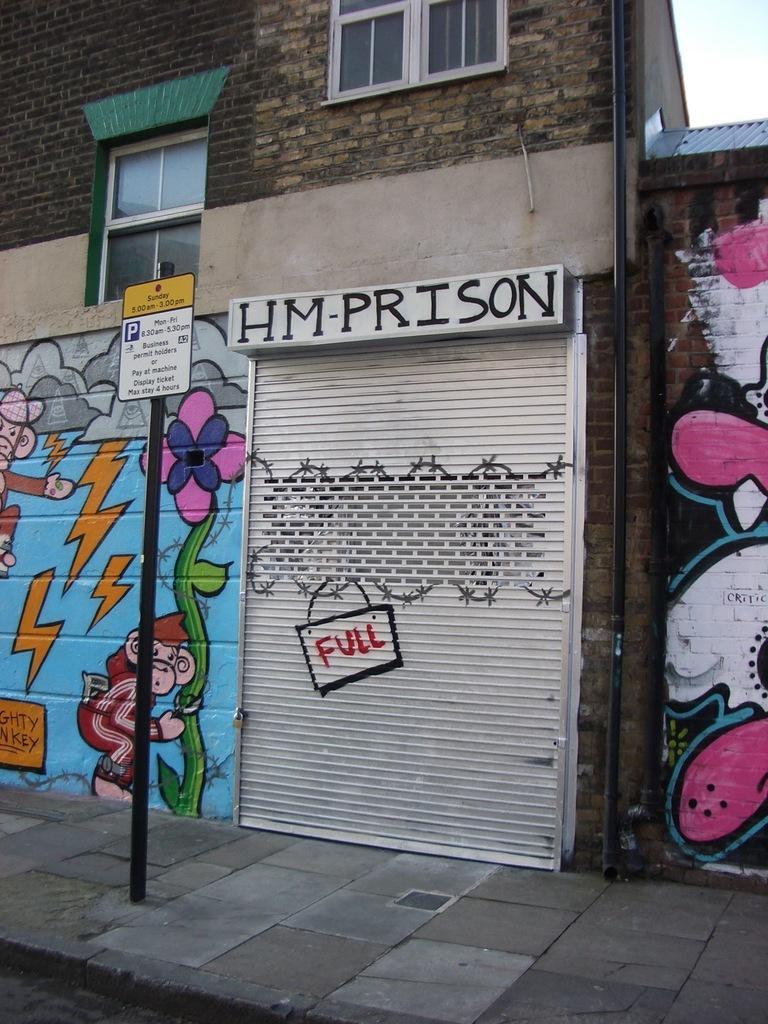Describe this image in one or two sentences. In this picture there is a shop in the center of the image and there are graffiti on the right and left side of the image and there are windows at the top side of the image, there is a pole on the left side of the image. 